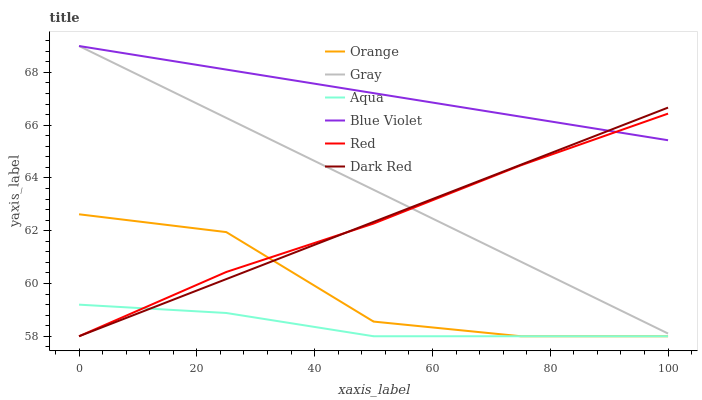Does Aqua have the minimum area under the curve?
Answer yes or no. Yes. Does Blue Violet have the maximum area under the curve?
Answer yes or no. Yes. Does Dark Red have the minimum area under the curve?
Answer yes or no. No. Does Dark Red have the maximum area under the curve?
Answer yes or no. No. Is Gray the smoothest?
Answer yes or no. Yes. Is Orange the roughest?
Answer yes or no. Yes. Is Dark Red the smoothest?
Answer yes or no. No. Is Dark Red the roughest?
Answer yes or no. No. Does Blue Violet have the lowest value?
Answer yes or no. No. Does Blue Violet have the highest value?
Answer yes or no. Yes. Does Dark Red have the highest value?
Answer yes or no. No. Is Aqua less than Blue Violet?
Answer yes or no. Yes. Is Gray greater than Orange?
Answer yes or no. Yes. Does Orange intersect Red?
Answer yes or no. Yes. Is Orange less than Red?
Answer yes or no. No. Is Orange greater than Red?
Answer yes or no. No. Does Aqua intersect Blue Violet?
Answer yes or no. No. 